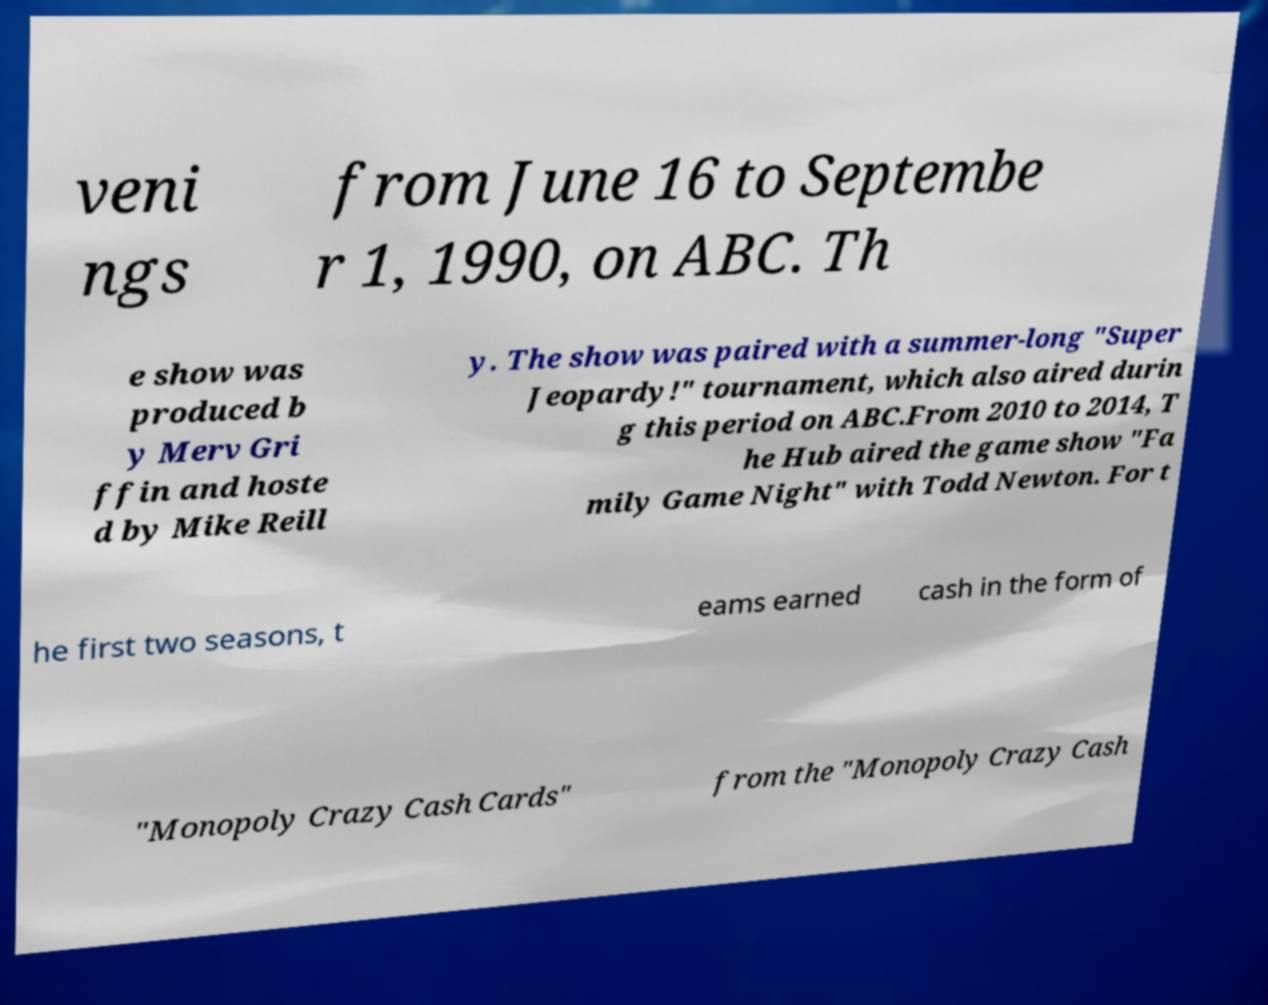There's text embedded in this image that I need extracted. Can you transcribe it verbatim? veni ngs from June 16 to Septembe r 1, 1990, on ABC. Th e show was produced b y Merv Gri ffin and hoste d by Mike Reill y. The show was paired with a summer-long "Super Jeopardy!" tournament, which also aired durin g this period on ABC.From 2010 to 2014, T he Hub aired the game show "Fa mily Game Night" with Todd Newton. For t he first two seasons, t eams earned cash in the form of "Monopoly Crazy Cash Cards" from the "Monopoly Crazy Cash 